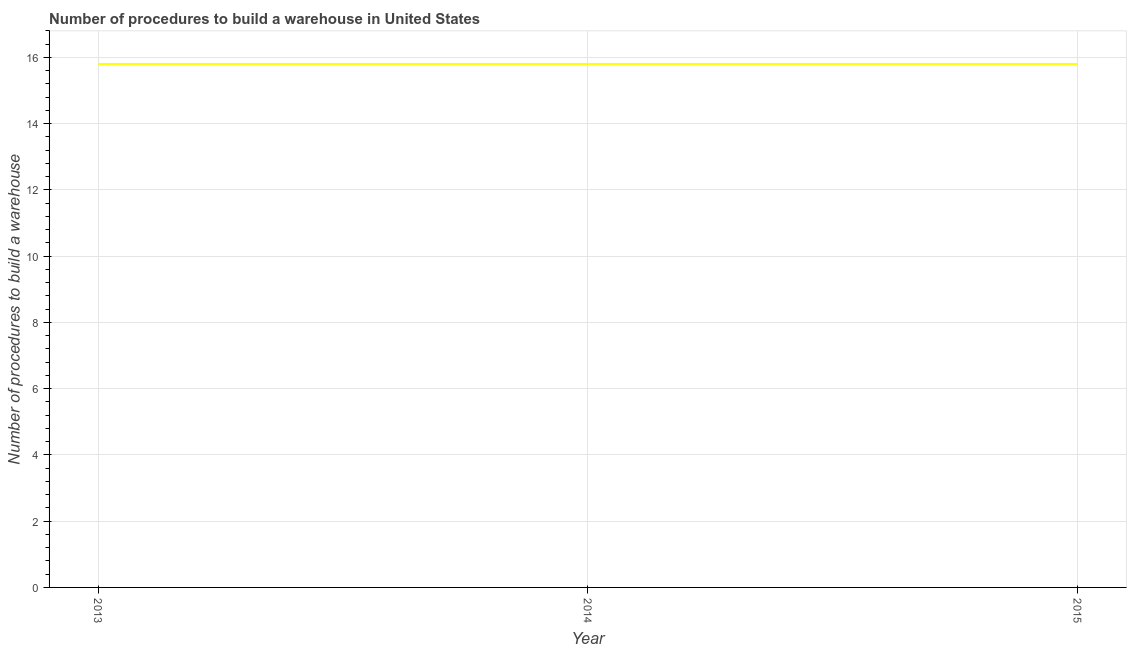What is the number of procedures to build a warehouse in 2013?
Your response must be concise. 15.8. Across all years, what is the maximum number of procedures to build a warehouse?
Keep it short and to the point. 15.8. In which year was the number of procedures to build a warehouse maximum?
Offer a terse response. 2013. In which year was the number of procedures to build a warehouse minimum?
Offer a very short reply. 2013. What is the sum of the number of procedures to build a warehouse?
Your answer should be very brief. 47.4. What is the average number of procedures to build a warehouse per year?
Your response must be concise. 15.8. In how many years, is the number of procedures to build a warehouse greater than 3.2 ?
Your answer should be compact. 3. Do a majority of the years between 2013 and 2014 (inclusive) have number of procedures to build a warehouse greater than 10.8 ?
Provide a short and direct response. Yes. Is the number of procedures to build a warehouse in 2014 less than that in 2015?
Your answer should be compact. No. Is the difference between the number of procedures to build a warehouse in 2013 and 2015 greater than the difference between any two years?
Make the answer very short. Yes. What is the difference between the highest and the lowest number of procedures to build a warehouse?
Keep it short and to the point. 0. In how many years, is the number of procedures to build a warehouse greater than the average number of procedures to build a warehouse taken over all years?
Provide a short and direct response. 0. How many lines are there?
Give a very brief answer. 1. How many years are there in the graph?
Offer a very short reply. 3. What is the difference between two consecutive major ticks on the Y-axis?
Your response must be concise. 2. Are the values on the major ticks of Y-axis written in scientific E-notation?
Offer a very short reply. No. Does the graph contain any zero values?
Offer a very short reply. No. Does the graph contain grids?
Provide a short and direct response. Yes. What is the title of the graph?
Give a very brief answer. Number of procedures to build a warehouse in United States. What is the label or title of the X-axis?
Your response must be concise. Year. What is the label or title of the Y-axis?
Keep it short and to the point. Number of procedures to build a warehouse. What is the Number of procedures to build a warehouse in 2013?
Your answer should be very brief. 15.8. What is the difference between the Number of procedures to build a warehouse in 2013 and 2015?
Ensure brevity in your answer.  0. What is the ratio of the Number of procedures to build a warehouse in 2013 to that in 2015?
Your answer should be compact. 1. 